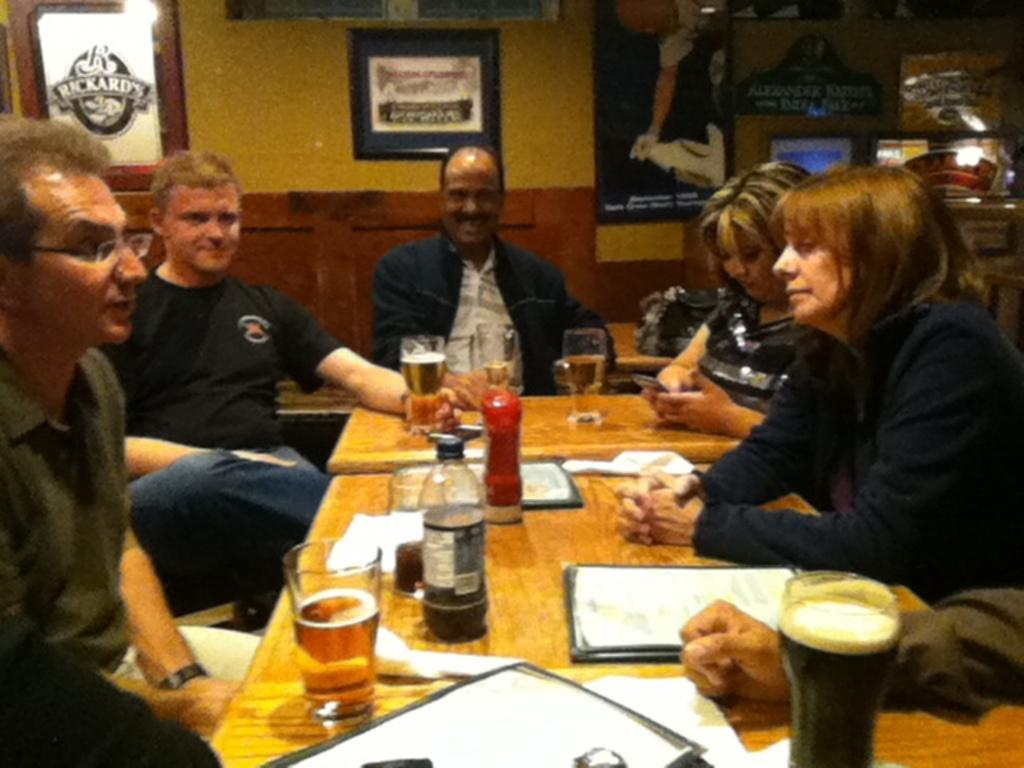How many people are sitting in the image? There are five people sitting on chairs in the image. What is on the table in the image? There is a paper, a glass, and a bottle on the table in the image. What can be seen on the wall behind the people? There are frames attached to the wall at the backside. What type of mint is being used to flavor the water in the kettle in the image? There is no kettle or mint present in the image. What degree do the people in the image have? The provided facts do not mention any degrees held by the people in the image. 